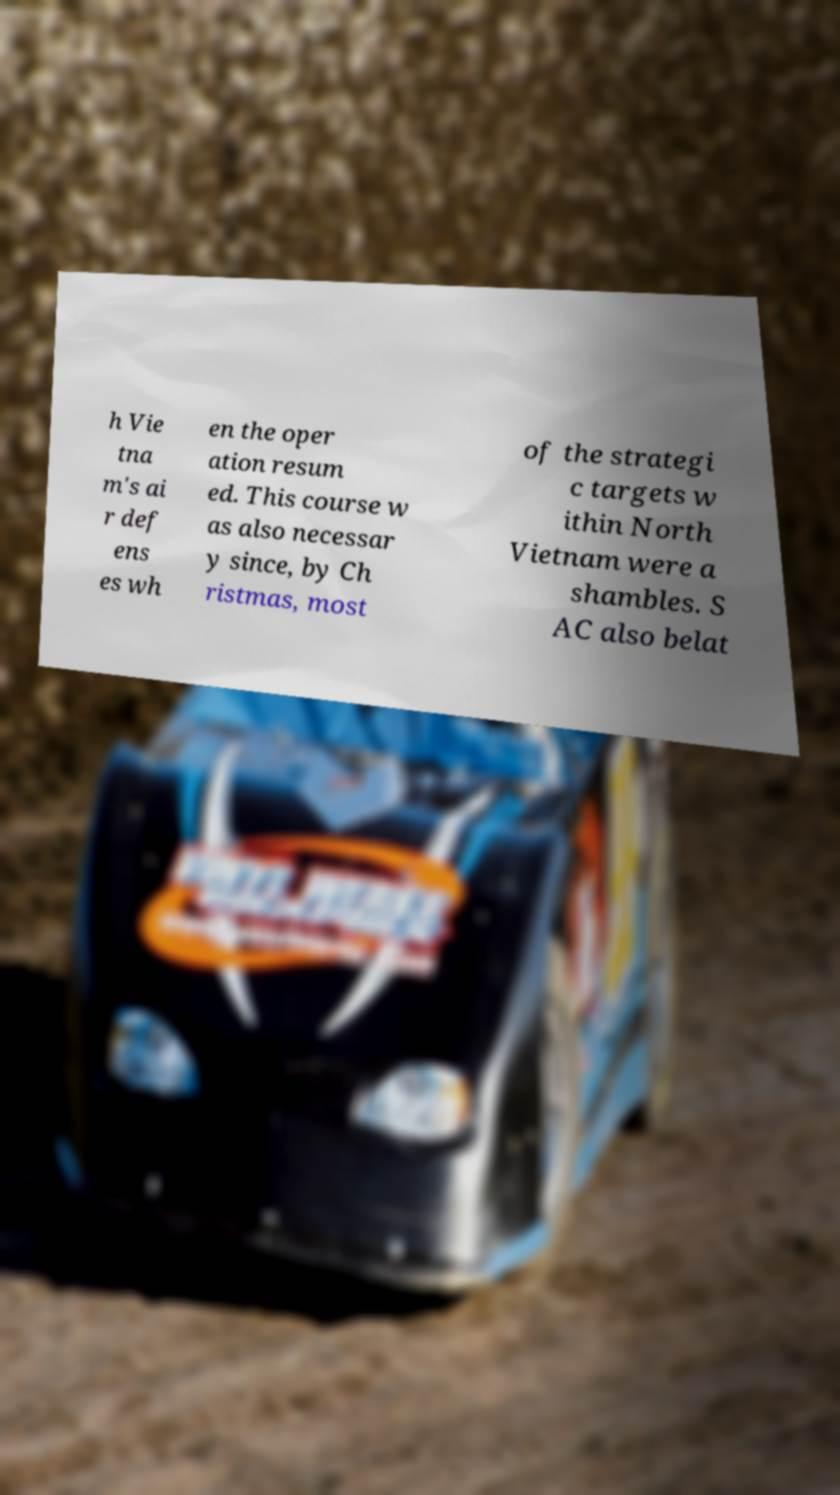What messages or text are displayed in this image? I need them in a readable, typed format. h Vie tna m's ai r def ens es wh en the oper ation resum ed. This course w as also necessar y since, by Ch ristmas, most of the strategi c targets w ithin North Vietnam were a shambles. S AC also belat 